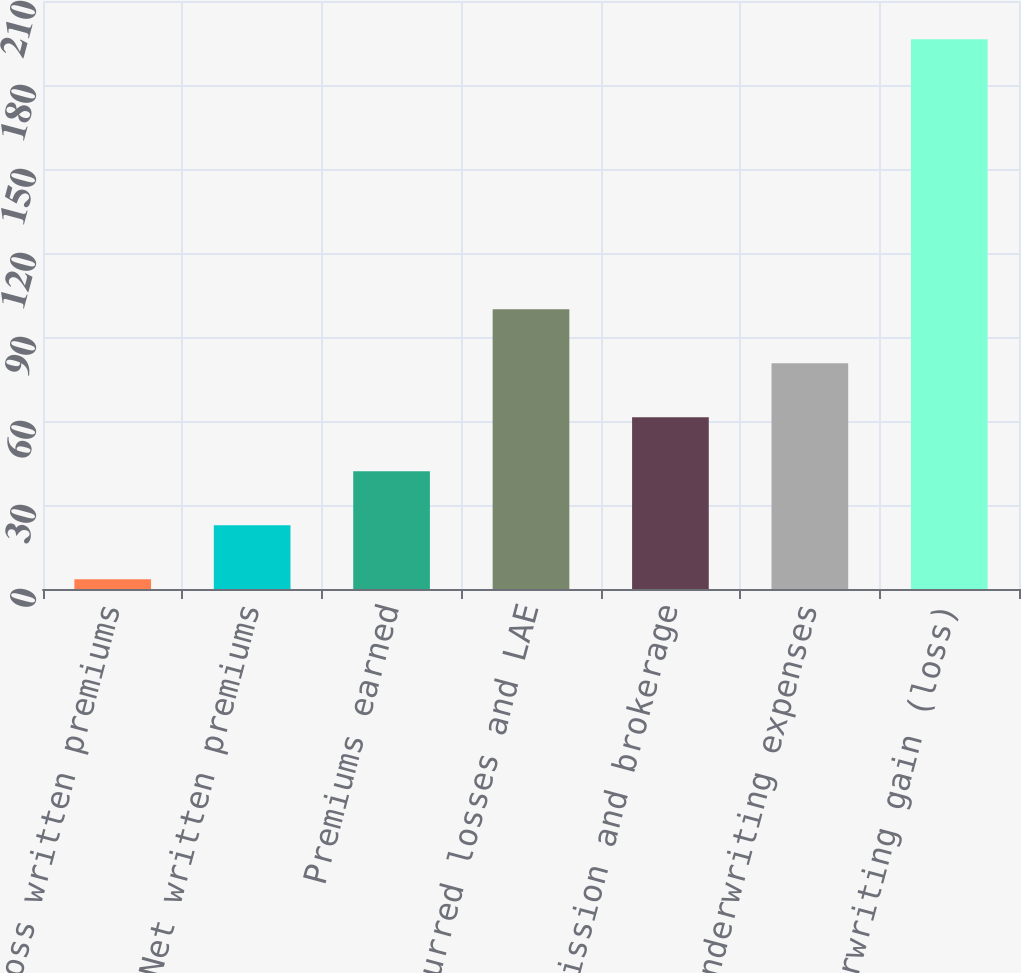Convert chart. <chart><loc_0><loc_0><loc_500><loc_500><bar_chart><fcel>Gross written premiums<fcel>Net written premiums<fcel>Premiums earned<fcel>Incurred losses and LAE<fcel>Commission and brokerage<fcel>Other underwriting expenses<fcel>Underwriting gain (loss)<nl><fcel>3.5<fcel>22.78<fcel>42.06<fcel>99.9<fcel>61.34<fcel>80.62<fcel>196.3<nl></chart> 